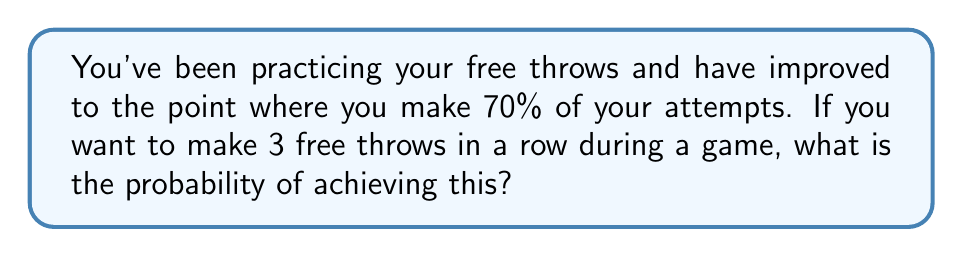Help me with this question. Let's approach this step-by-step:

1) First, we need to understand what the question is asking. We're looking for the probability of making 3 consecutive free throws, given that you have a 70% chance of making each individual shot.

2) In probability, when we want multiple independent events to all occur, we multiply the probabilities of each individual event.

3) The probability of making one free throw is 70%, or 0.7 in decimal form.

4) We need this to happen three times in a row. So we calculate:

   $$(0.7) \cdot (0.7) \cdot (0.7) = (0.7)^3$$

5) Let's compute this:

   $$(0.7)^3 = 0.343$$

6) To convert to a percentage, we multiply by 100:

   $$0.343 \cdot 100 = 34.3\%$$

Therefore, the probability of making 3 free throws in a row, given a 70% success rate for each shot, is approximately 34.3%.
Answer: 34.3% 